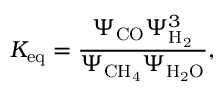Convert formula to latex. <formula><loc_0><loc_0><loc_500><loc_500>K _ { e q } = \frac { \Psi _ { C O } \Psi _ { H _ { 2 } } ^ { 3 } } { \Psi _ { C H _ { 4 } } \Psi _ { H _ { 2 } O } } ,</formula> 